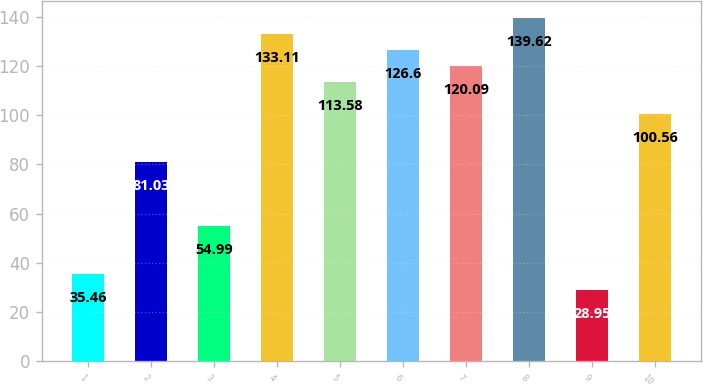Convert chart. <chart><loc_0><loc_0><loc_500><loc_500><bar_chart><fcel>1<fcel>2<fcel>3<fcel>4<fcel>5<fcel>6<fcel>7<fcel>8<fcel>9<fcel>10<nl><fcel>35.46<fcel>81.03<fcel>54.99<fcel>133.11<fcel>113.58<fcel>126.6<fcel>120.09<fcel>139.62<fcel>28.95<fcel>100.56<nl></chart> 